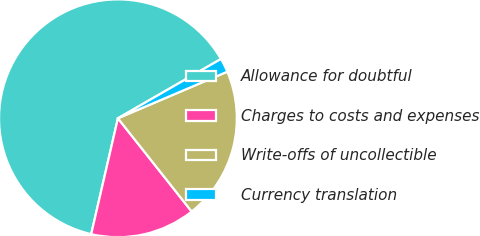Convert chart to OTSL. <chart><loc_0><loc_0><loc_500><loc_500><pie_chart><fcel>Allowance for doubtful<fcel>Charges to costs and expenses<fcel>Write-offs of uncollectible<fcel>Currency translation<nl><fcel>63.07%<fcel>14.26%<fcel>20.76%<fcel>1.9%<nl></chart> 